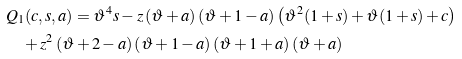<formula> <loc_0><loc_0><loc_500><loc_500>& Q _ { 1 } ( c , s , a ) = { \vartheta } ^ { 4 } s - z \left ( \vartheta + a \right ) \left ( \vartheta + 1 - a \right ) \left ( { \vartheta } ^ { 2 } ( 1 + s ) + \vartheta ( 1 + s ) + c \right ) \\ & \quad + { z } ^ { 2 } \left ( \vartheta + 2 - a \right ) \left ( \vartheta + 1 - a \right ) \left ( \vartheta + 1 + a \right ) \left ( \vartheta + a \right )</formula> 